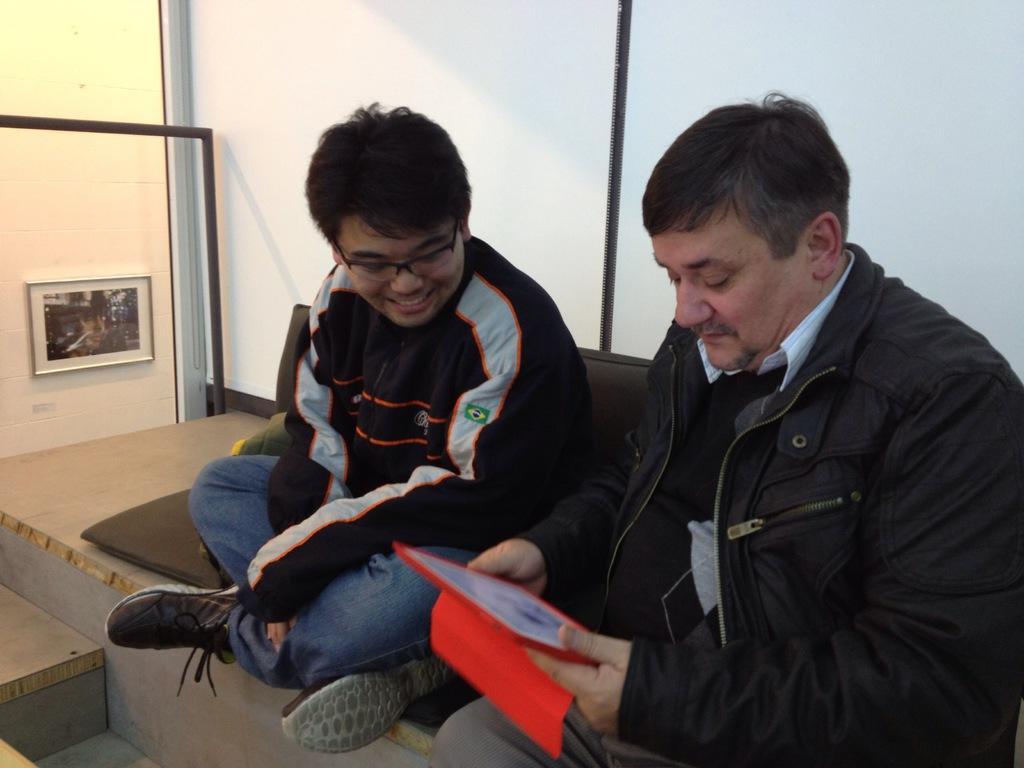In one or two sentences, can you explain what this image depicts? In this image we can see two persons sitting on the wooden box in which one of them is wearing goggles and the other is holding a tab, there we can see a window, frame, an object on the wooden box, outside the window we can see a frame attached to the wall. 